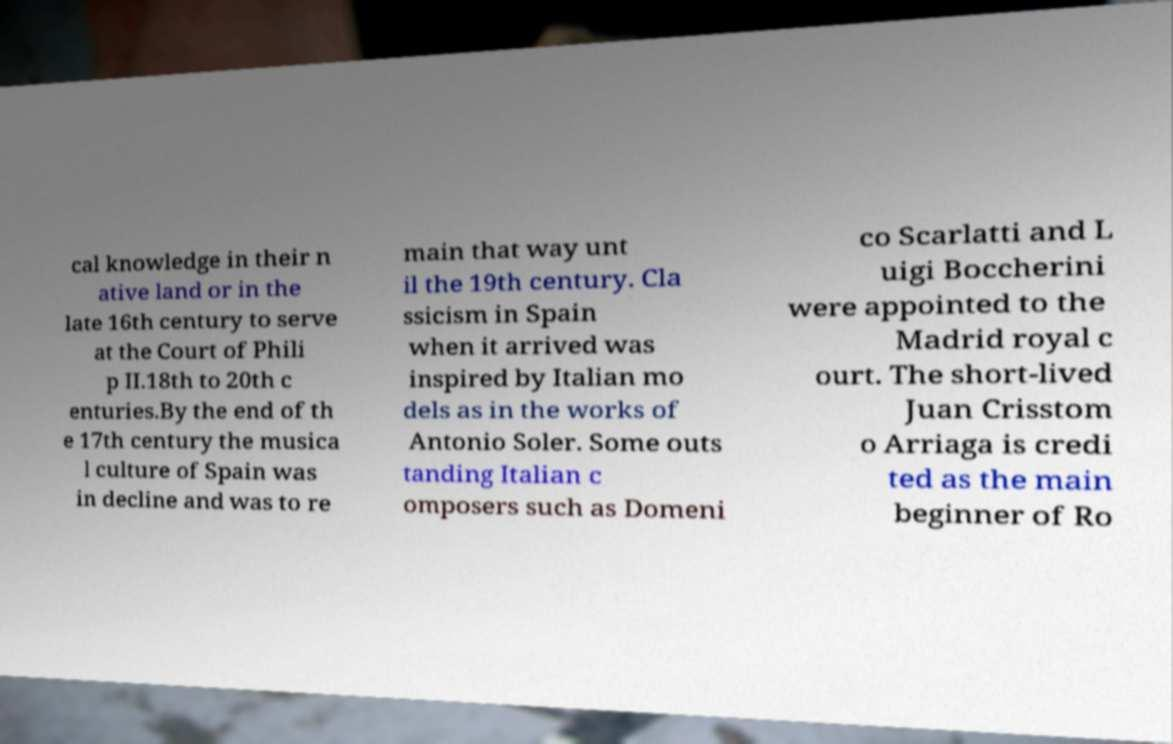I need the written content from this picture converted into text. Can you do that? cal knowledge in their n ative land or in the late 16th century to serve at the Court of Phili p II.18th to 20th c enturies.By the end of th e 17th century the musica l culture of Spain was in decline and was to re main that way unt il the 19th century. Cla ssicism in Spain when it arrived was inspired by Italian mo dels as in the works of Antonio Soler. Some outs tanding Italian c omposers such as Domeni co Scarlatti and L uigi Boccherini were appointed to the Madrid royal c ourt. The short-lived Juan Crisstom o Arriaga is credi ted as the main beginner of Ro 